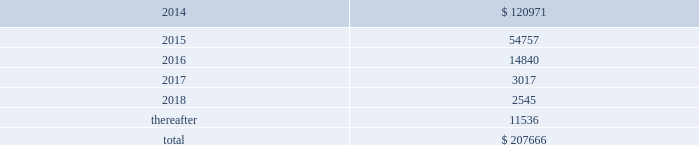Interest expense related to capital lease obligations was $ 1.7 million during both the years ended december 31 , 2013 and 2012 , and $ 1.5 million during the year ended december 31 , 2011 .
Purchase commitments in the table below , we set forth our enforceable and legally binding purchase obligations as of december 31 , 2013 .
Some of the amounts included in the table are based on management 2019s estimates and assumptions about these obligations , including their duration , the possibility of renewal , anticipated actions by third parties , and other factors .
Because these estimates and assumptions are necessarily subjective , our actual payments may vary from those reflected in the table .
Purchase orders made in the ordinary course of business are excluded from the table below .
Any amounts for which we are liable under purchase orders are reflected on the consolidated balance sheets as accounts payable and accrued liabilities .
These obligations relate to various purchase agreements for items such as minimum amounts of fiber and energy purchases over periods ranging from one to 15 years .
Total purchase commitments are as follows ( dollars in thousands ) : .
The company purchased a total of $ 61.7 million , $ 27.7 million , and $ 28.5 million during the years ended december 31 , 2013 , 2012 , and 2011 , respectively , under these purchase agreements .
The increase in purchase commitments in 2014 , compared with 2013 , relates to the acquisition of boise in fourth quarter 2013 .
Environmental liabilities the potential costs for various environmental matters are uncertain due to such factors as the unknown magnitude of possible cleanup costs , the complexity and evolving nature of governmental laws and regulations and their interpretations , and the timing , varying costs and effectiveness of alternative cleanup technologies .
From 1994 through 2013 , remediation costs at the company 2019s mills and corrugated plants totaled approximately $ 3.2 million .
At december 31 , 2013 , the company had $ 34.1 million of environmental-related reserves recorded on its consolidated balance sheet .
Of the $ 34.1 million , approximately $ 26.5 million related to environmental- related asset retirement obligations discussed in note 14 , asset retirement obligations , and $ 7.6 million related to our estimate of other environmental contingencies .
The company recorded $ 7.8 million in 201caccrued liabilities 201d and $ 26.3 million in 201cother long-term liabilities 201d on the consolidated balance sheet .
Liabilities recorded for environmental contingencies are estimates of the probable costs based upon available information and assumptions .
Because of these uncertainties , pca 2019s estimates may change .
As of the date of this filing , the company believes that it is not reasonably possible that future environmental expenditures for remediation costs and asset retirement obligations above the $ 34.1 million accrued as of december 31 , 2013 , will have a material impact on its financial condition , results of operations , or cash flows .
Guarantees and indemnifications we provide guarantees , indemnifications , and other assurances to third parties in the normal course of our business .
These include tort indemnifications , environmental assurances , and representations and warranties in commercial agreements .
At december 31 , 2013 , we are not aware of any material liabilities arising from any guarantee , indemnification , or financial assurance we have provided .
If we determined such a liability was probable and subject to reasonable determination , we would accrue for it at that time. .
What percentage of total purchase commitments are due after 2018? 
Computations: (11536 / 207666)
Answer: 0.05555. 